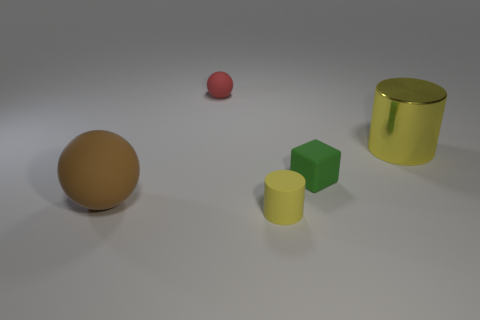Subtract all red spheres. How many spheres are left? 1 Subtract all cylinders. How many objects are left? 3 Subtract 1 balls. How many balls are left? 1 Add 4 tiny green cubes. How many objects exist? 9 Subtract all purple spheres. How many blue cylinders are left? 0 Subtract all big metallic things. Subtract all small green objects. How many objects are left? 3 Add 3 small yellow matte cylinders. How many small yellow matte cylinders are left? 4 Add 4 tiny matte cubes. How many tiny matte cubes exist? 5 Subtract 0 blue cylinders. How many objects are left? 5 Subtract all red cubes. Subtract all cyan balls. How many cubes are left? 1 